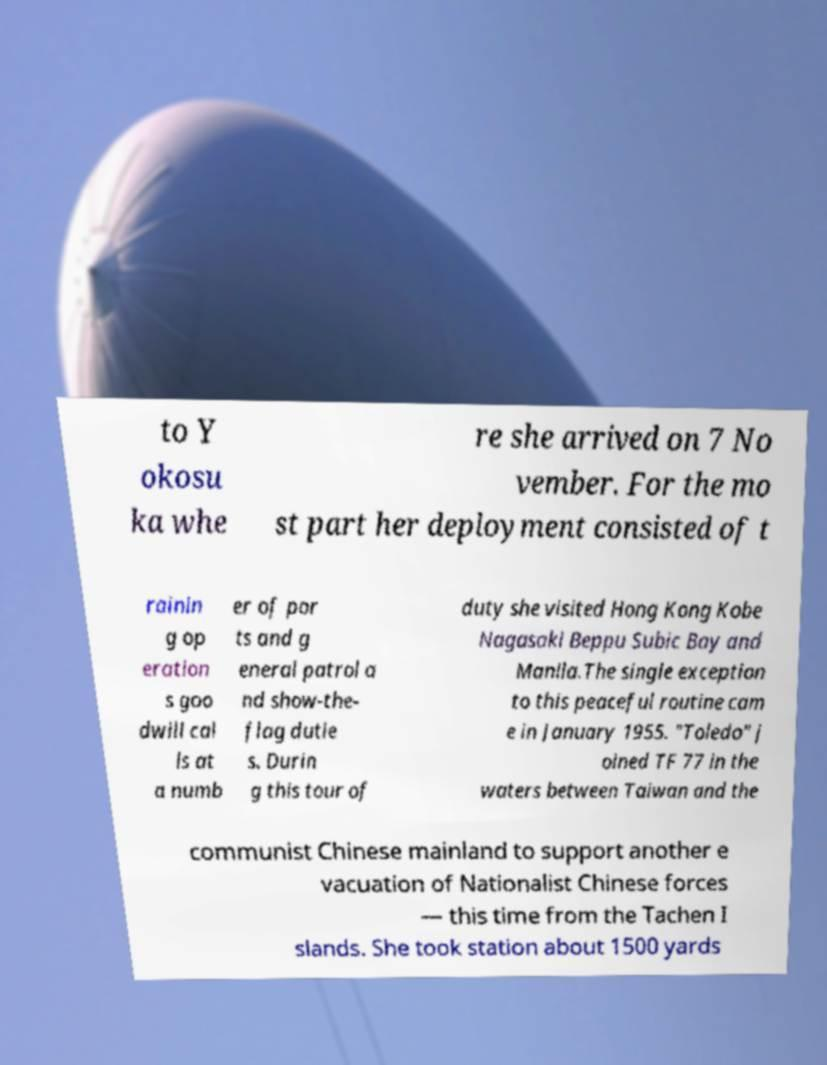Can you read and provide the text displayed in the image?This photo seems to have some interesting text. Can you extract and type it out for me? to Y okosu ka whe re she arrived on 7 No vember. For the mo st part her deployment consisted of t rainin g op eration s goo dwill cal ls at a numb er of por ts and g eneral patrol a nd show-the- flag dutie s. Durin g this tour of duty she visited Hong Kong Kobe Nagasaki Beppu Subic Bay and Manila.The single exception to this peaceful routine cam e in January 1955. "Toledo" j oined TF 77 in the waters between Taiwan and the communist Chinese mainland to support another e vacuation of Nationalist Chinese forces — this time from the Tachen I slands. She took station about 1500 yards 